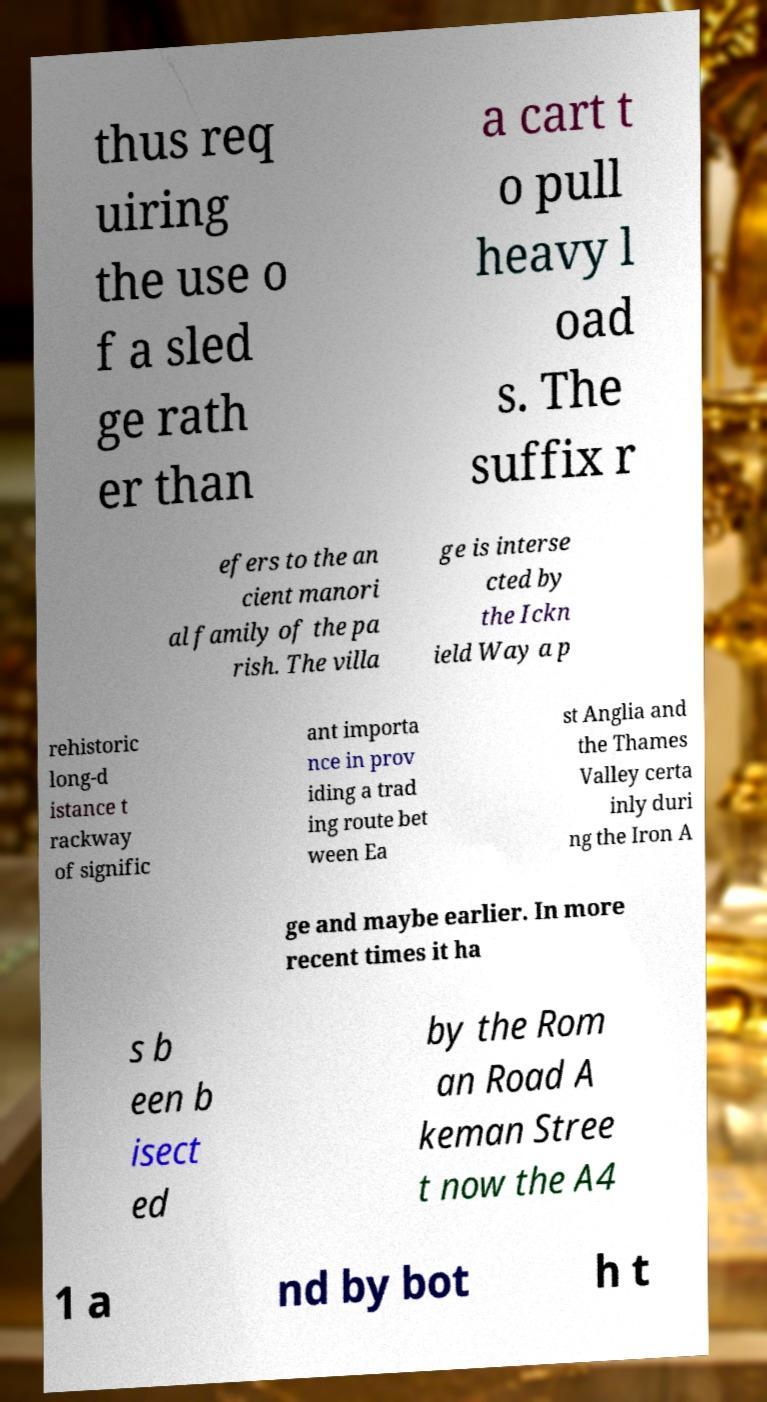Can you read and provide the text displayed in the image?This photo seems to have some interesting text. Can you extract and type it out for me? thus req uiring the use o f a sled ge rath er than a cart t o pull heavy l oad s. The suffix r efers to the an cient manori al family of the pa rish. The villa ge is interse cted by the Ickn ield Way a p rehistoric long-d istance t rackway of signific ant importa nce in prov iding a trad ing route bet ween Ea st Anglia and the Thames Valley certa inly duri ng the Iron A ge and maybe earlier. In more recent times it ha s b een b isect ed by the Rom an Road A keman Stree t now the A4 1 a nd by bot h t 